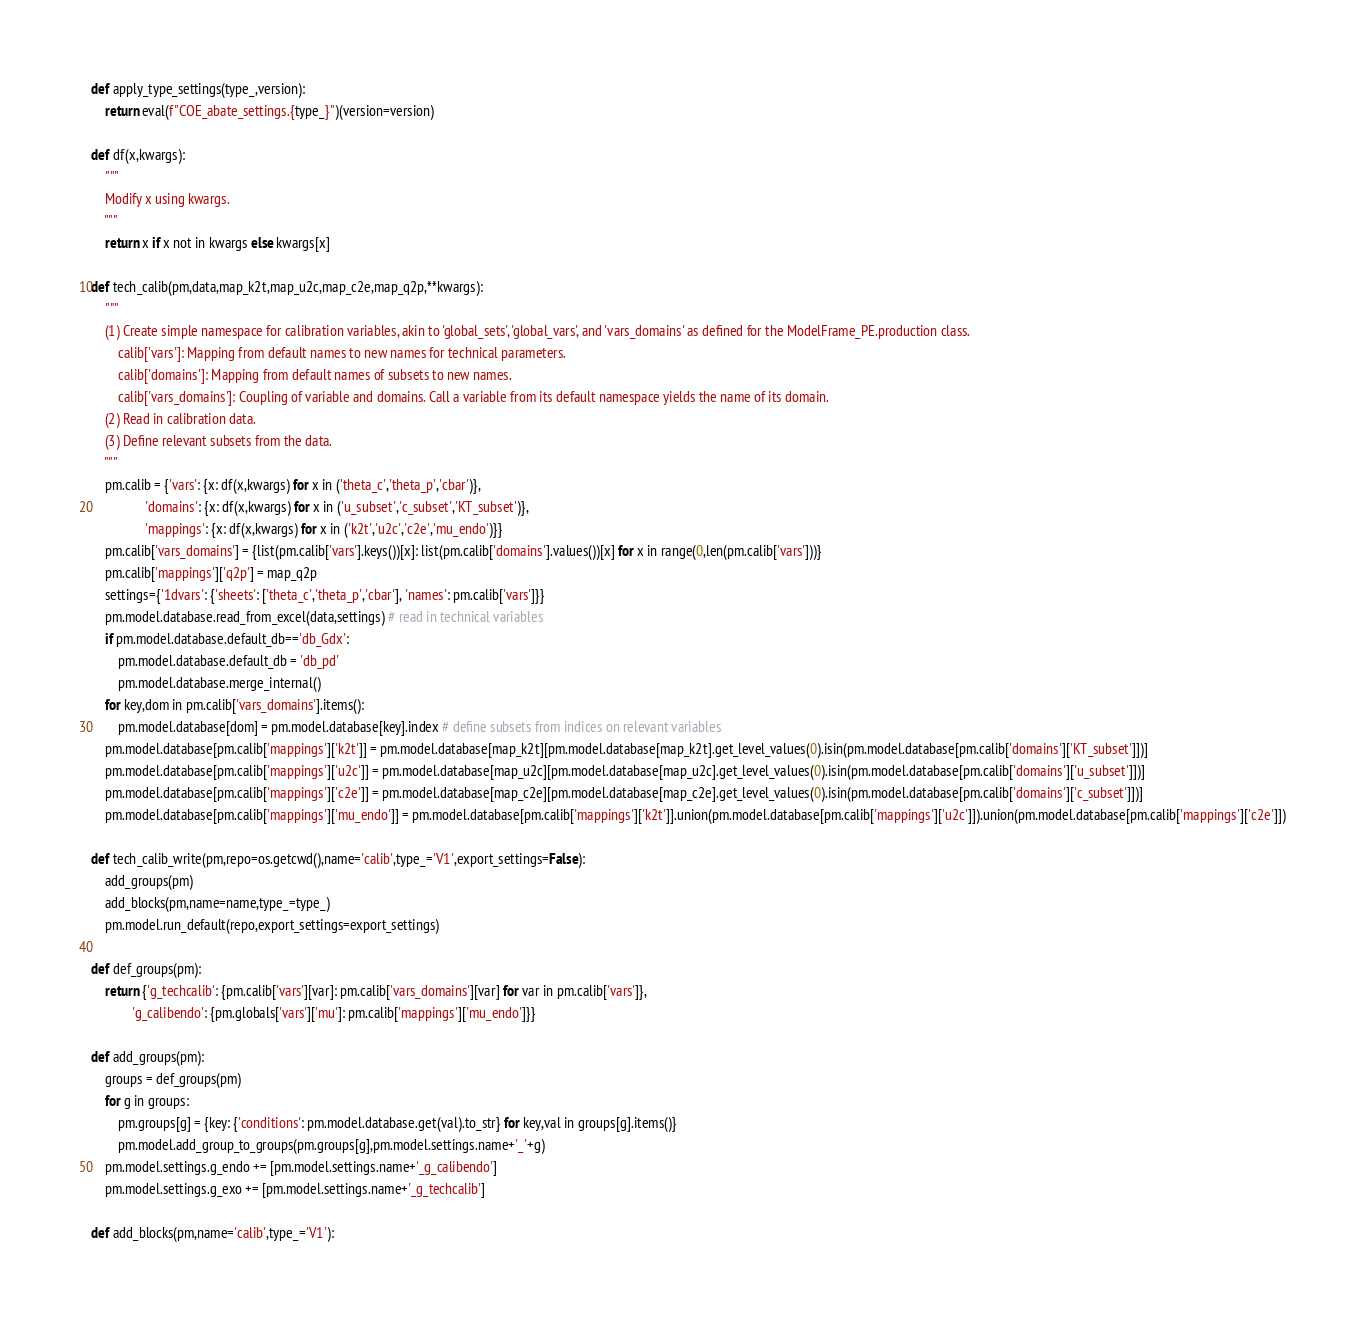Convert code to text. <code><loc_0><loc_0><loc_500><loc_500><_Python_>
def apply_type_settings(type_,version):
	return eval(f"COE_abate_settings.{type_}")(version=version)

def df(x,kwargs):
	"""
	Modify x using kwargs.
	"""
	return x if x not in kwargs else kwargs[x]

def tech_calib(pm,data,map_k2t,map_u2c,map_c2e,map_q2p,**kwargs):
	"""
	(1) Create simple namespace for calibration variables, akin to 'global_sets', 'global_vars', and 'vars_domains' as defined for the ModelFrame_PE.production class. 
		calib['vars']: Mapping from default names to new names for technical parameters.
		calib['domains']: Mapping from default names of subsets to new names.
		calib['vars_domains']: Coupling of variable and domains. Call a variable from its default namespace yields the name of its domain.
	(2) Read in calibration data.
	(3) Define relevant subsets from the data.
	"""
	pm.calib = {'vars': {x: df(x,kwargs) for x in ('theta_c','theta_p','cbar')},
				'domains': {x: df(x,kwargs) for x in ('u_subset','c_subset','KT_subset')}, 
				'mappings': {x: df(x,kwargs) for x in ('k2t','u2c','c2e','mu_endo')}}
	pm.calib['vars_domains'] = {list(pm.calib['vars'].keys())[x]: list(pm.calib['domains'].values())[x] for x in range(0,len(pm.calib['vars']))}
	pm.calib['mappings']['q2p'] = map_q2p
	settings={'1dvars': {'sheets': ['theta_c','theta_p','cbar'], 'names': pm.calib['vars']}}
	pm.model.database.read_from_excel(data,settings) # read in technical variables
	if pm.model.database.default_db=='db_Gdx':
		pm.model.database.default_db = 'db_pd'
		pm.model.database.merge_internal()
	for key,dom in pm.calib['vars_domains'].items():
		pm.model.database[dom] = pm.model.database[key].index # define subsets from indices on relevant variables
	pm.model.database[pm.calib['mappings']['k2t']] = pm.model.database[map_k2t][pm.model.database[map_k2t].get_level_values(0).isin(pm.model.database[pm.calib['domains']['KT_subset']])]
	pm.model.database[pm.calib['mappings']['u2c']] = pm.model.database[map_u2c][pm.model.database[map_u2c].get_level_values(0).isin(pm.model.database[pm.calib['domains']['u_subset']])]
	pm.model.database[pm.calib['mappings']['c2e']] = pm.model.database[map_c2e][pm.model.database[map_c2e].get_level_values(0).isin(pm.model.database[pm.calib['domains']['c_subset']])]
	pm.model.database[pm.calib['mappings']['mu_endo']] = pm.model.database[pm.calib['mappings']['k2t']].union(pm.model.database[pm.calib['mappings']['u2c']]).union(pm.model.database[pm.calib['mappings']['c2e']])

def tech_calib_write(pm,repo=os.getcwd(),name='calib',type_='V1',export_settings=False):
	add_groups(pm)
	add_blocks(pm,name=name,type_=type_)
	pm.model.run_default(repo,export_settings=export_settings)

def def_groups(pm):
	return {'g_techcalib': {pm.calib['vars'][var]: pm.calib['vars_domains'][var] for var in pm.calib['vars']},
			'g_calibendo': {pm.globals['vars']['mu']: pm.calib['mappings']['mu_endo']}}

def add_groups(pm):
	groups = def_groups(pm)
	for g in groups:
		pm.groups[g] = {key: {'conditions': pm.model.database.get(val).to_str} for key,val in groups[g].items()}
		pm.model.add_group_to_groups(pm.groups[g],pm.model.settings.name+'_'+g)
	pm.model.settings.g_endo += [pm.model.settings.name+'_g_calibendo']
	pm.model.settings.g_exo += [pm.model.settings.name+'_g_techcalib']

def add_blocks(pm,name='calib',type_='V1'):</code> 